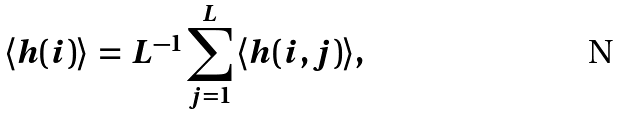Convert formula to latex. <formula><loc_0><loc_0><loc_500><loc_500>\langle h ( i ) \rangle \, = \, L ^ { - 1 } \sum ^ { L } _ { j = 1 } \, \langle h ( i , j ) \rangle ,</formula> 